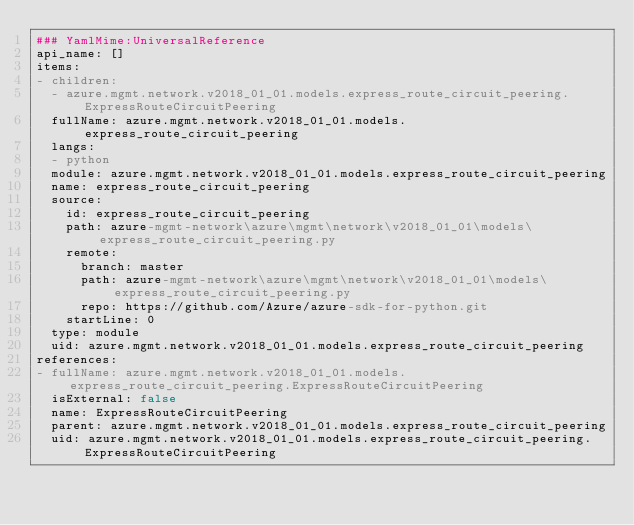Convert code to text. <code><loc_0><loc_0><loc_500><loc_500><_YAML_>### YamlMime:UniversalReference
api_name: []
items:
- children:
  - azure.mgmt.network.v2018_01_01.models.express_route_circuit_peering.ExpressRouteCircuitPeering
  fullName: azure.mgmt.network.v2018_01_01.models.express_route_circuit_peering
  langs:
  - python
  module: azure.mgmt.network.v2018_01_01.models.express_route_circuit_peering
  name: express_route_circuit_peering
  source:
    id: express_route_circuit_peering
    path: azure-mgmt-network\azure\mgmt\network\v2018_01_01\models\express_route_circuit_peering.py
    remote:
      branch: master
      path: azure-mgmt-network\azure\mgmt\network\v2018_01_01\models\express_route_circuit_peering.py
      repo: https://github.com/Azure/azure-sdk-for-python.git
    startLine: 0
  type: module
  uid: azure.mgmt.network.v2018_01_01.models.express_route_circuit_peering
references:
- fullName: azure.mgmt.network.v2018_01_01.models.express_route_circuit_peering.ExpressRouteCircuitPeering
  isExternal: false
  name: ExpressRouteCircuitPeering
  parent: azure.mgmt.network.v2018_01_01.models.express_route_circuit_peering
  uid: azure.mgmt.network.v2018_01_01.models.express_route_circuit_peering.ExpressRouteCircuitPeering
</code> 